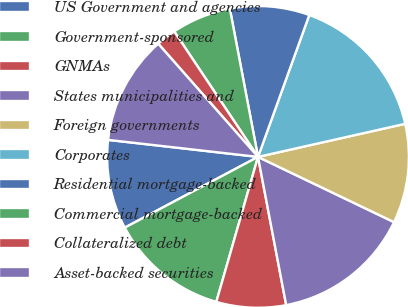Convert chart to OTSL. <chart><loc_0><loc_0><loc_500><loc_500><pie_chart><fcel>US Government and agencies<fcel>Government-sponsored<fcel>GNMAs<fcel>States municipalities and<fcel>Foreign governments<fcel>Corporates<fcel>Residential mortgage-backed<fcel>Commercial mortgage-backed<fcel>Collateralized debt<fcel>Asset-backed securities<nl><fcel>9.57%<fcel>12.77%<fcel>7.45%<fcel>14.89%<fcel>10.64%<fcel>15.96%<fcel>8.51%<fcel>6.38%<fcel>2.13%<fcel>11.7%<nl></chart> 